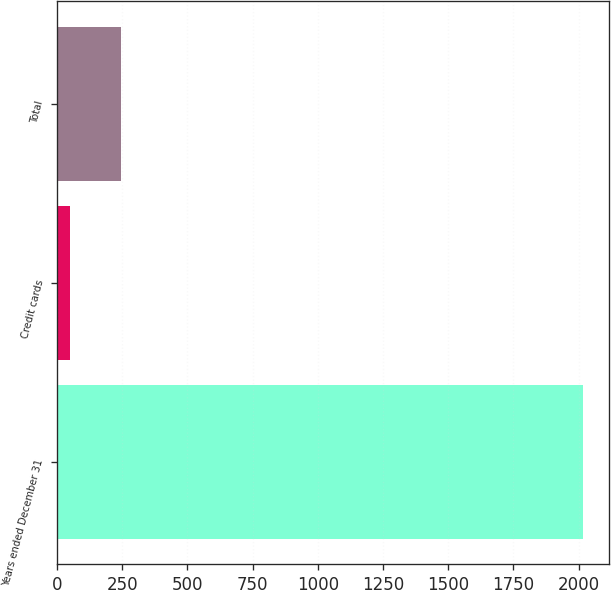Convert chart. <chart><loc_0><loc_0><loc_500><loc_500><bar_chart><fcel>Years ended December 31<fcel>Credit cards<fcel>Total<nl><fcel>2016<fcel>48<fcel>244.8<nl></chart> 